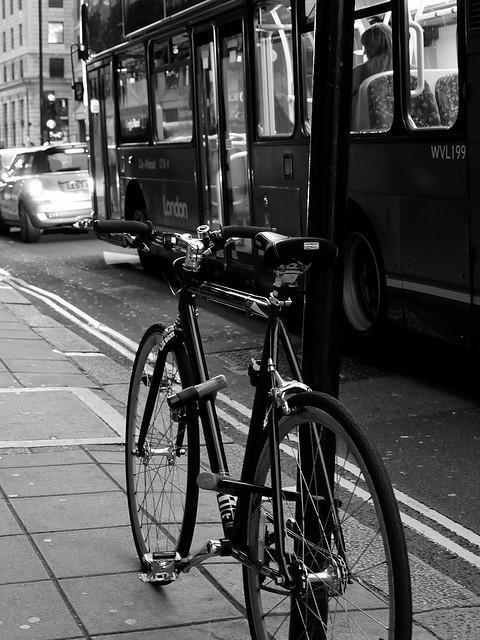Does the image validate the caption "The bicycle is near the bus."?
Answer yes or no. Yes. 